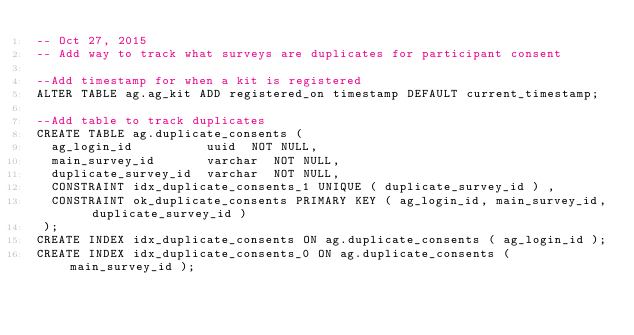<code> <loc_0><loc_0><loc_500><loc_500><_SQL_>-- Oct 27, 2015
-- Add way to track what surveys are duplicates for participant consent

--Add timestamp for when a kit is registered
ALTER TABLE ag.ag_kit ADD registered_on timestamp DEFAULT current_timestamp;

--Add table to track duplicates
CREATE TABLE ag.duplicate_consents ( 
	ag_login_id          uuid  NOT NULL,
	main_survey_id       varchar  NOT NULL,
	duplicate_survey_id  varchar  NOT NULL,
	CONSTRAINT idx_duplicate_consents_1 UNIQUE ( duplicate_survey_id ) ,
	CONSTRAINT ok_duplicate_consents PRIMARY KEY ( ag_login_id, main_survey_id, duplicate_survey_id )
 );
CREATE INDEX idx_duplicate_consents ON ag.duplicate_consents ( ag_login_id );
CREATE INDEX idx_duplicate_consents_0 ON ag.duplicate_consents ( main_survey_id );
</code> 